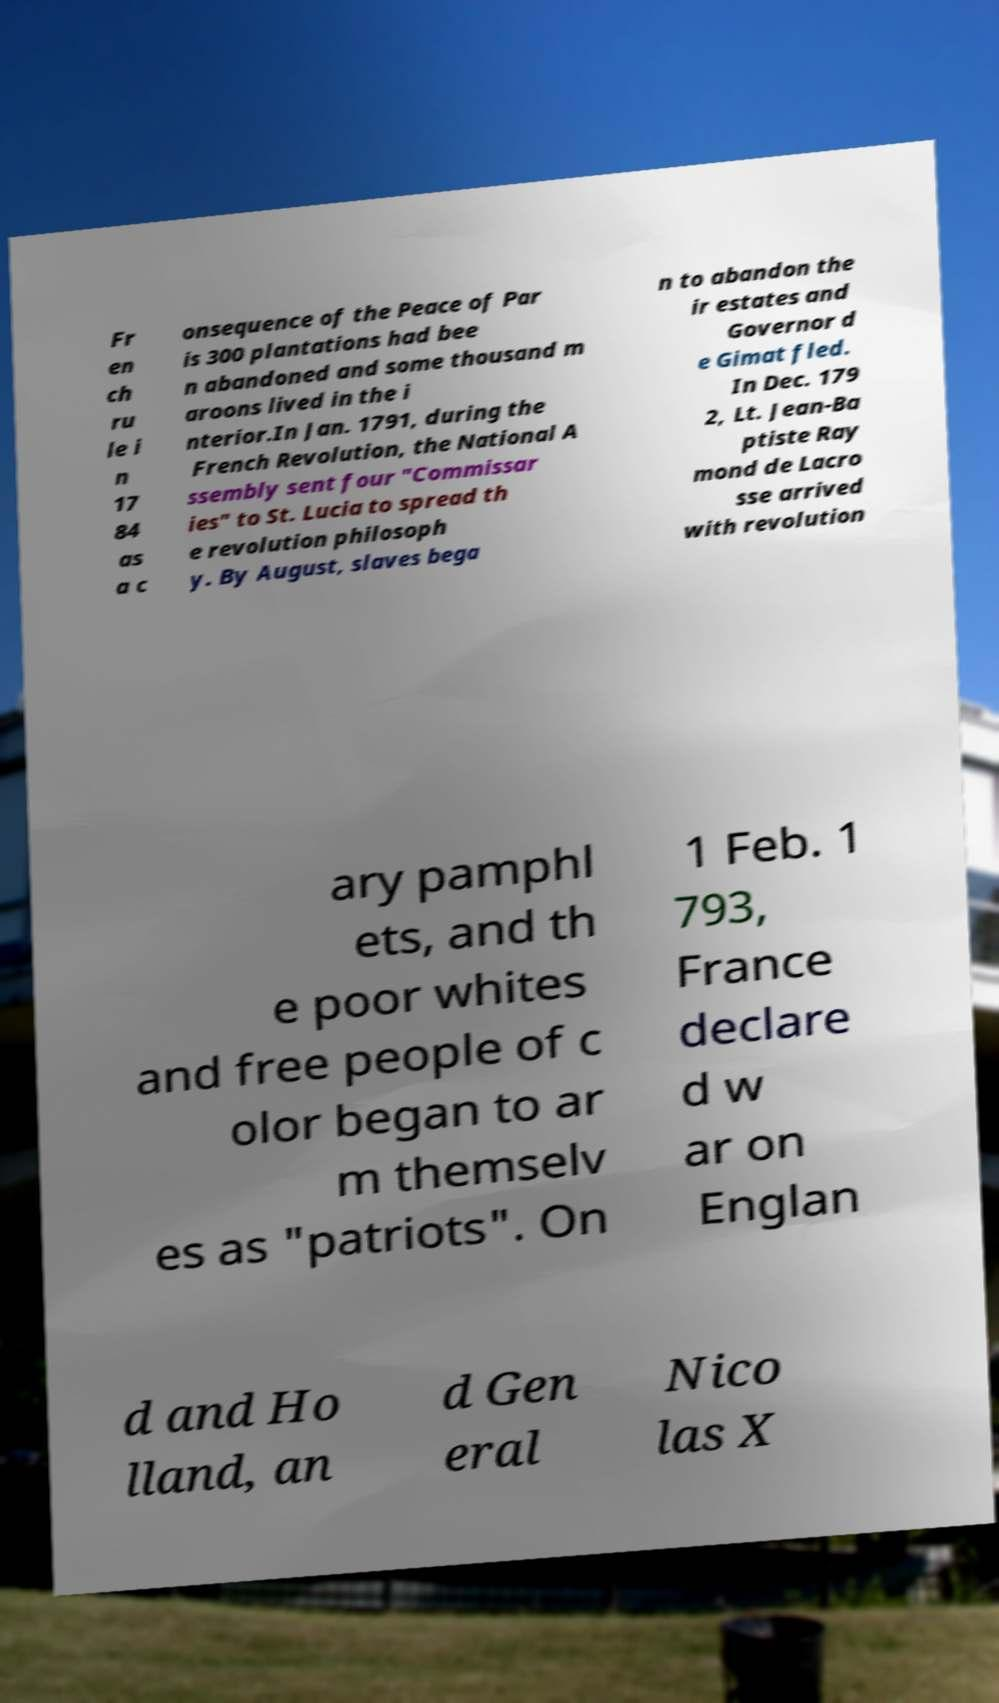Can you accurately transcribe the text from the provided image for me? Fr en ch ru le i n 17 84 as a c onsequence of the Peace of Par is 300 plantations had bee n abandoned and some thousand m aroons lived in the i nterior.In Jan. 1791, during the French Revolution, the National A ssembly sent four "Commissar ies" to St. Lucia to spread th e revolution philosoph y. By August, slaves bega n to abandon the ir estates and Governor d e Gimat fled. In Dec. 179 2, Lt. Jean-Ba ptiste Ray mond de Lacro sse arrived with revolution ary pamphl ets, and th e poor whites and free people of c olor began to ar m themselv es as "patriots". On 1 Feb. 1 793, France declare d w ar on Englan d and Ho lland, an d Gen eral Nico las X 